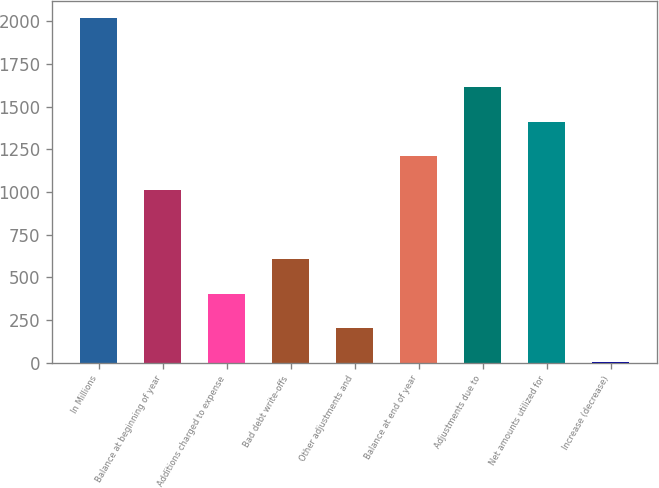Convert chart to OTSL. <chart><loc_0><loc_0><loc_500><loc_500><bar_chart><fcel>In Millions<fcel>Balance at beginning of year<fcel>Additions charged to expense<fcel>Bad debt write-offs<fcel>Other adjustments and<fcel>Balance at end of year<fcel>Adjustments due to<fcel>Net amounts utilized for<fcel>Increase (decrease)<nl><fcel>2019<fcel>1009.65<fcel>404.04<fcel>605.91<fcel>202.17<fcel>1211.52<fcel>1615.26<fcel>1413.39<fcel>0.3<nl></chart> 